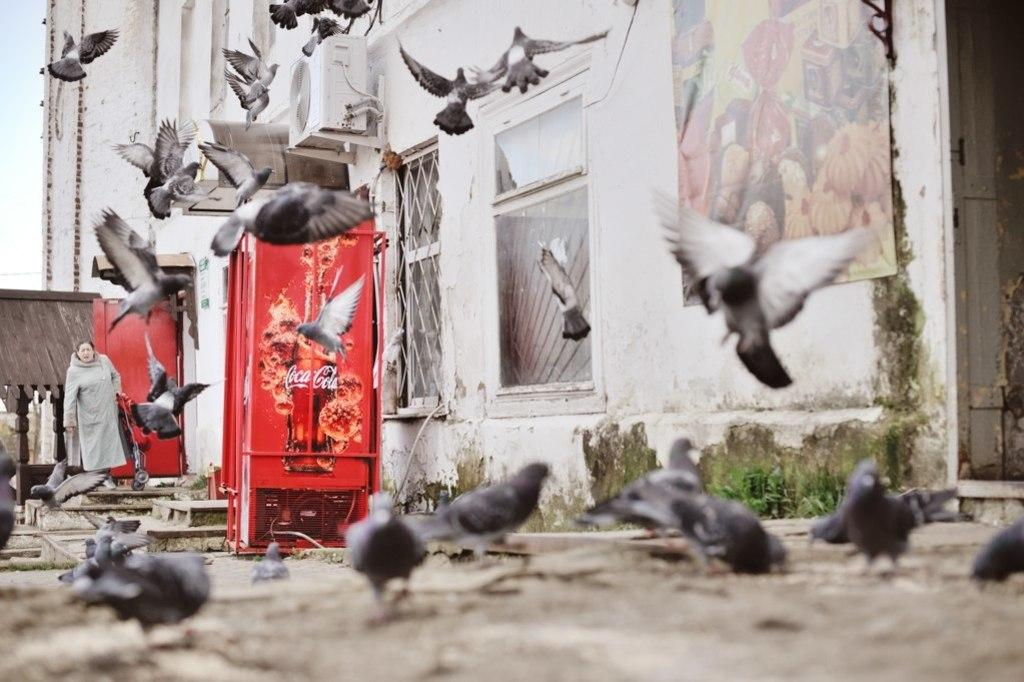What type of animals can be seen in the image? There are birds in the image. Where is the lady located in the image? The lady is on the left side of the image. What object is near the lady? There is a trolley near the lady. What type of appliances are present in the image? There are refrigerators in the image. What can be seen in the background of the image? There is a building, a poster, a door, and the sky visible in the background of the image. What type of vein is visible in the image? There is no vein visible in the image. What government policy is being discussed in the image? There is no discussion of government policy in the image. 